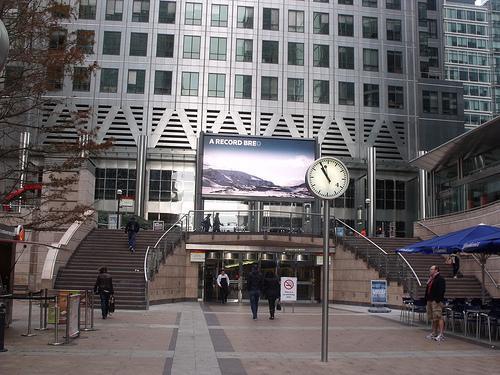How many staircases are in this picture?
Give a very brief answer. 2. How many people are on the staircases total?
Give a very brief answer. 3. How many people are on the stairs?
Give a very brief answer. 2. 